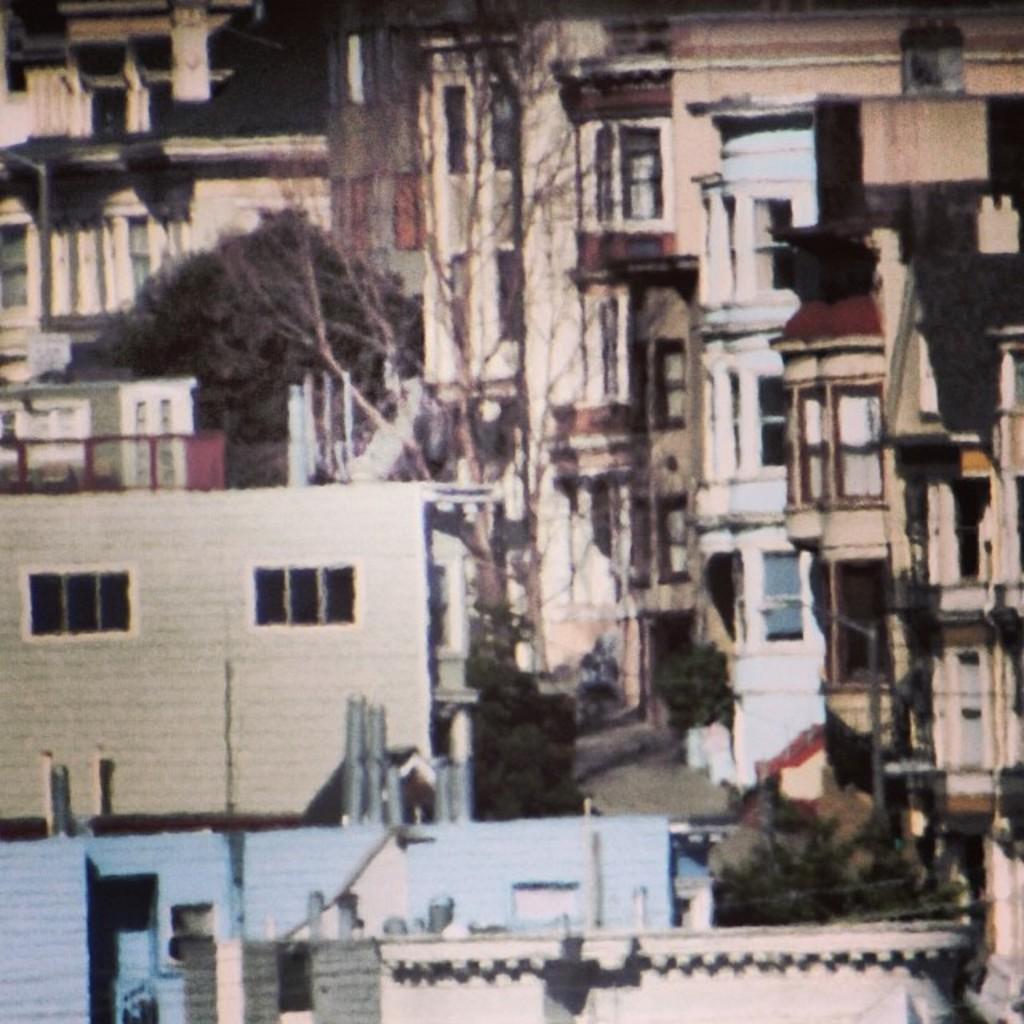Describe this image in one or two sentences. In the picture we can see some houses, buildings and near to it, we can see some trees. 